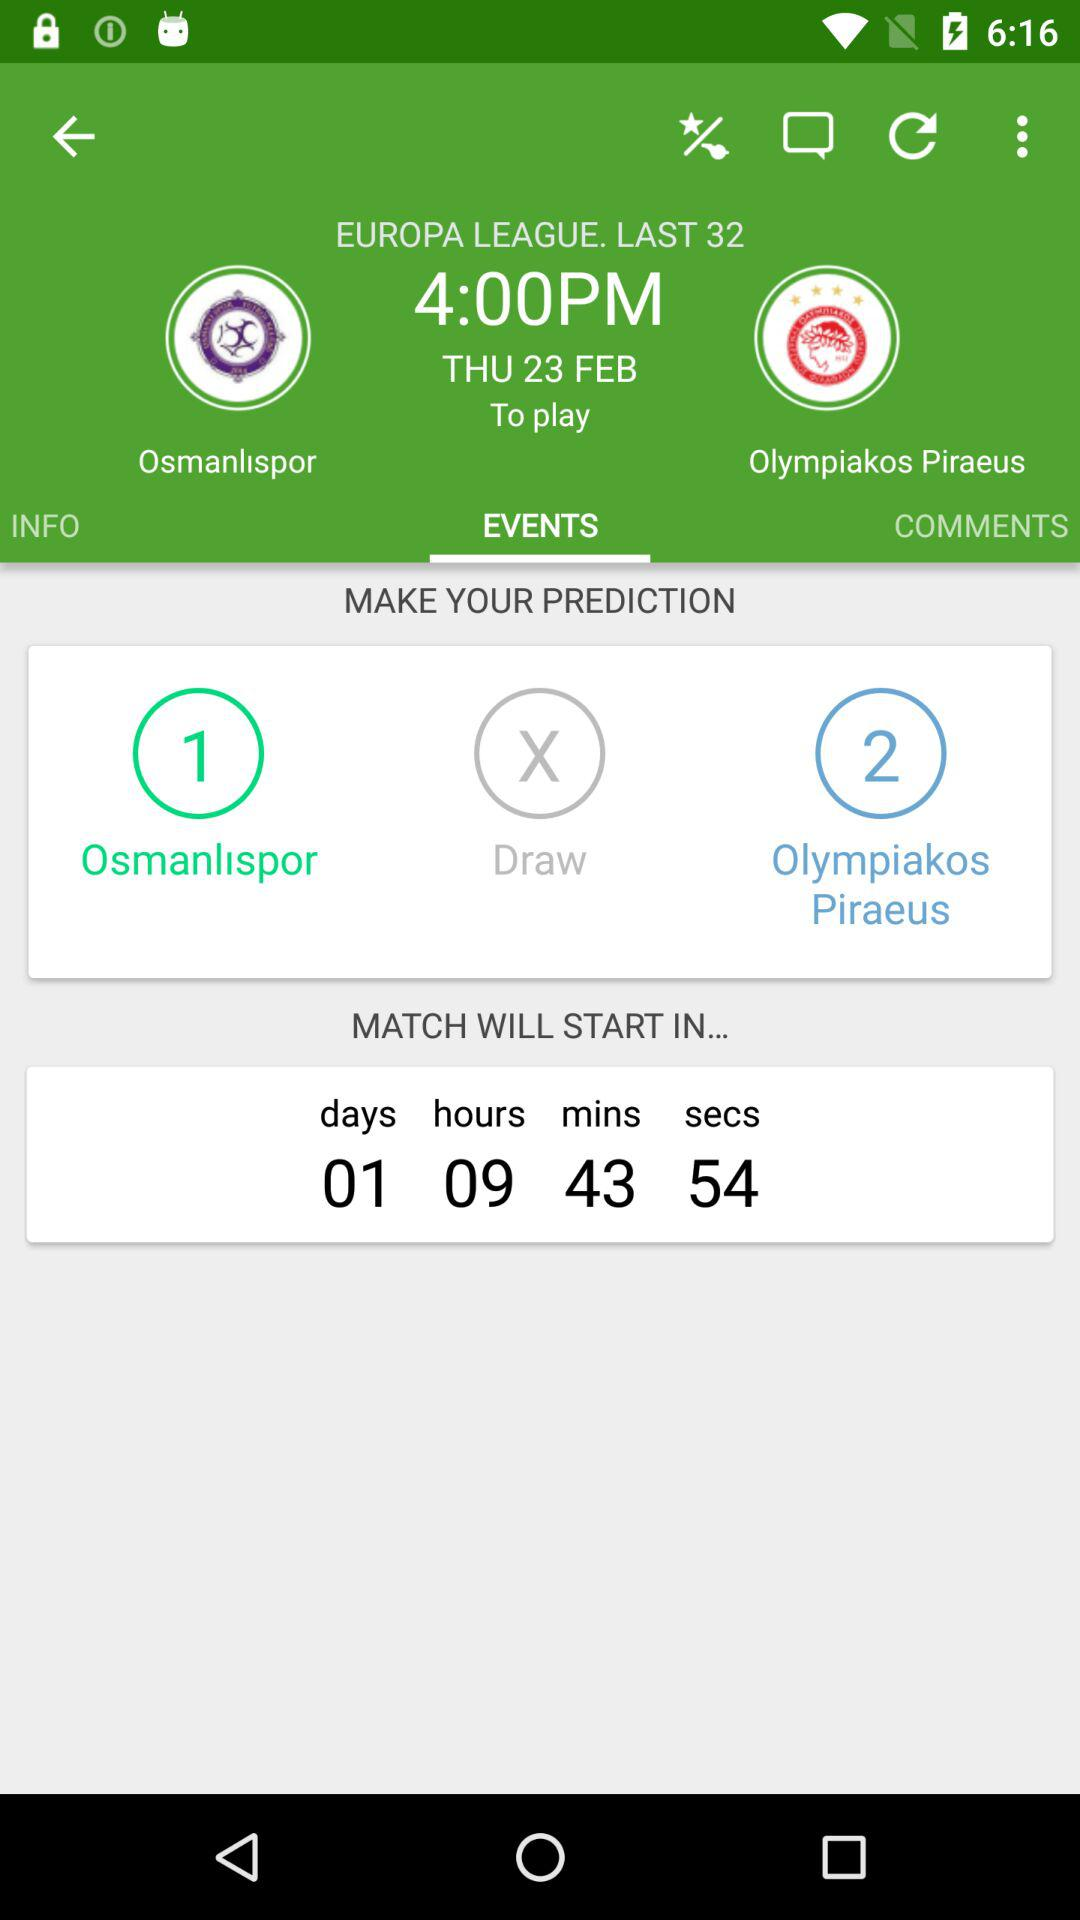What is the selected tab? The selected tab is "EVENTS". 